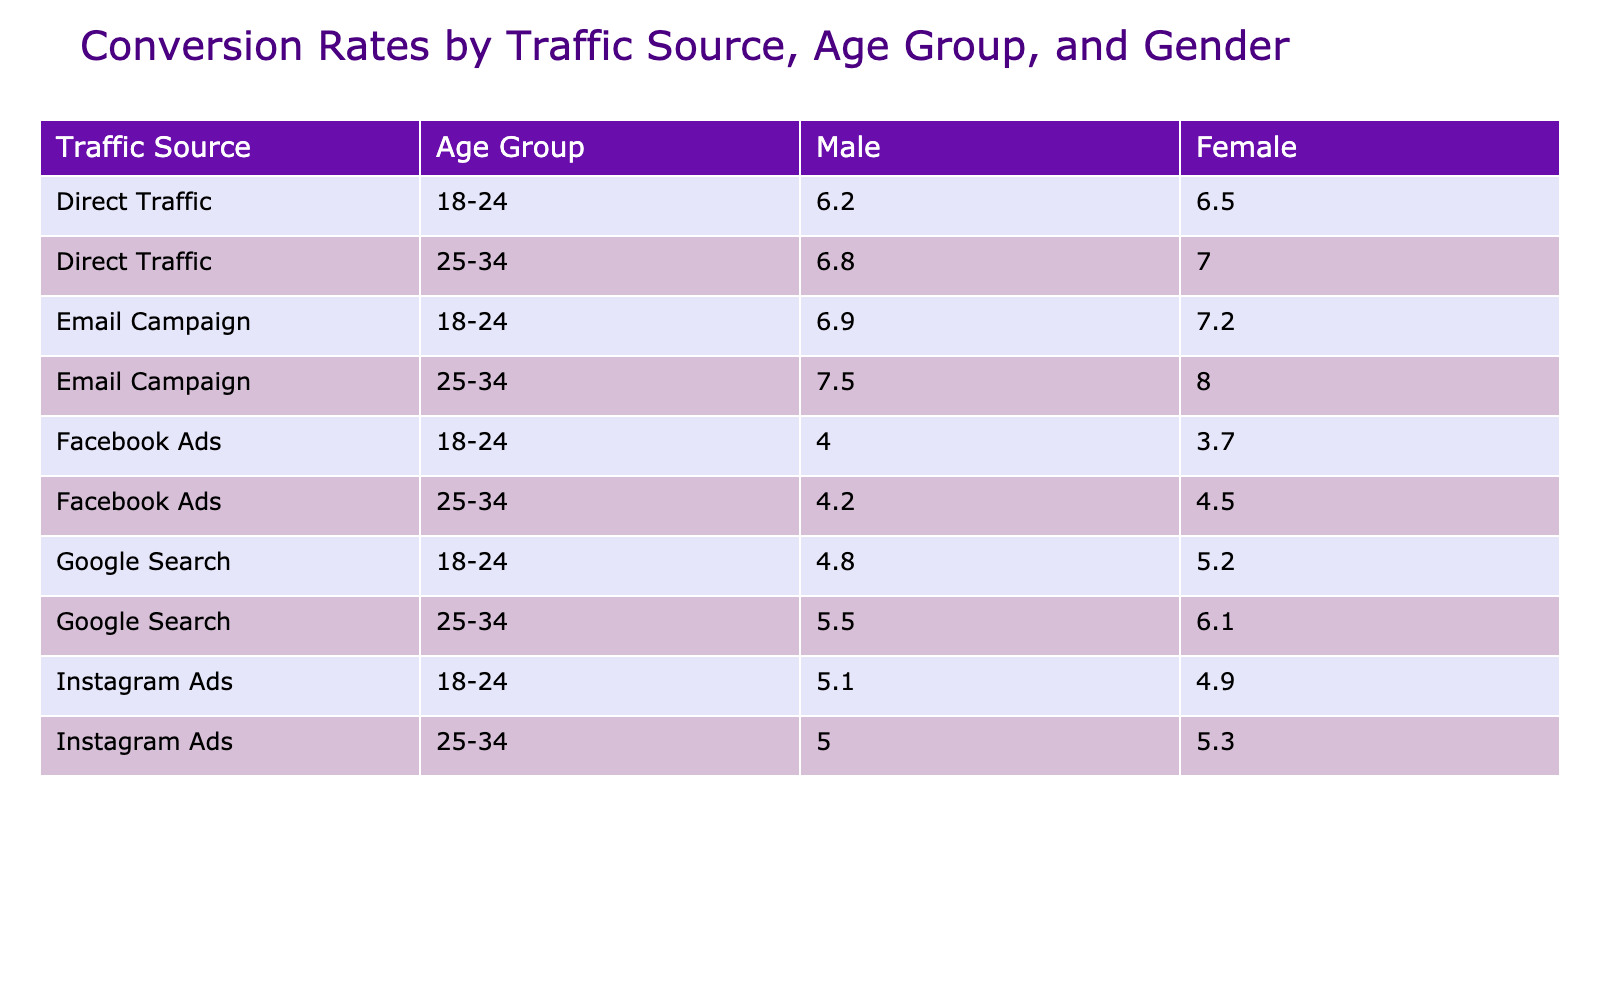What is the conversion rate for female users in the 25-34 age group from Email Campaigns? The table shows the conversion rate for female users aged 25-34 under the 'Email Campaign' traffic source. The specific entry for this demographic is listed as 7.5%.
Answer: 7.5% What is the conversion rate for male users from Direct Traffic in the 18-24 age group? Looking at the 'Direct Traffic' row for the 18-24 age group, the conversion rate for male users is specifically noted as 6.5%.
Answer: 6.5% Which traffic source has the highest conversion rate for females aged 18-24? To find this, we compare the conversion rates for females across all traffic sources in the 18-24 age group. The highest value found is from 'Email Campaign,' which is 6.9%.
Answer: 6.9% What is the average conversion rate for males across all traffic sources in the 25-34 age group? For the 25-34 age group, the conversion rates for males are: 6.1 (Google Search), 4.5 (Facebook Ads), 5.3 (Instagram Ads), 8.0 (Email Campaign), and 7.0 (Direct Traffic). The sum is 31.9, and dividing by 5 gives an average of 6.38.
Answer: 6.38 Is the conversion rate for Facebook Ads higher for males or females in the 18-24 age group? The table lists the conversion rate as 3.7% for males and 4.0% for females in the 18-24 age group. Since 4.0% is higher, we can conclude that females have a higher conversion rate.
Answer: Yes Which gender has a higher overall conversion rate from Google Search in the 18-24 age group? For the Google Search traffic source and the 18-24 age group, the conversion rates are 5.2% for males and 4.8% for females. Males have the higher rate, thus the answer is males.
Answer: Males Among the traffic sources, is the conversion rate for Instagram Ads in the 25-34 age group lower than that for Email Campaigns? The conversion rate for males in Instagram Ads for the 25-34 age group is 5.3%, and for females it's 5.0%, while for Email Campaigns it's 8.0% for males and 7.5% for females. Both rates for Email Campaigns are higher than those for Instagram Ads in the same age group.
Answer: Yes What is the difference in conversion rate between male and female users in the 25-34 age group for Direct Traffic? For males, the conversion rate for Direct Traffic in the 25-34 age group is 7.0% and for females, it is 6.8%. The difference is 7.0% - 6.8% = 0.2%.
Answer: 0.2% What is the highest conversion rate for any traffic source in the 18-24 age group? Analyzing the conversion rates for the 18-24 age group, we find: 5.2% (Google Search, Male), 4.8% (Google Search, Female), 3.7% (Facebook Ads, Male), 4.0% (Facebook Ads, Female), 4.9% (Instagram Ads, Male), 5.1% (Instagram Ads, Female), 7.2% (Email Campaign, Male), 6.9% (Email Campaign, Female), 6.5% (Direct Traffic, Male), and 6.2% (Direct Traffic, Female). The highest is 7.2% from the Email Campaign.
Answer: 7.2% 